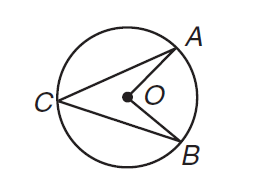Question: What is the ratio of the measure of \angle A C B to the measure of \angle A O B?
Choices:
A. 0.5
B. 1
C. 2
D. not enough information
Answer with the letter. Answer: A 